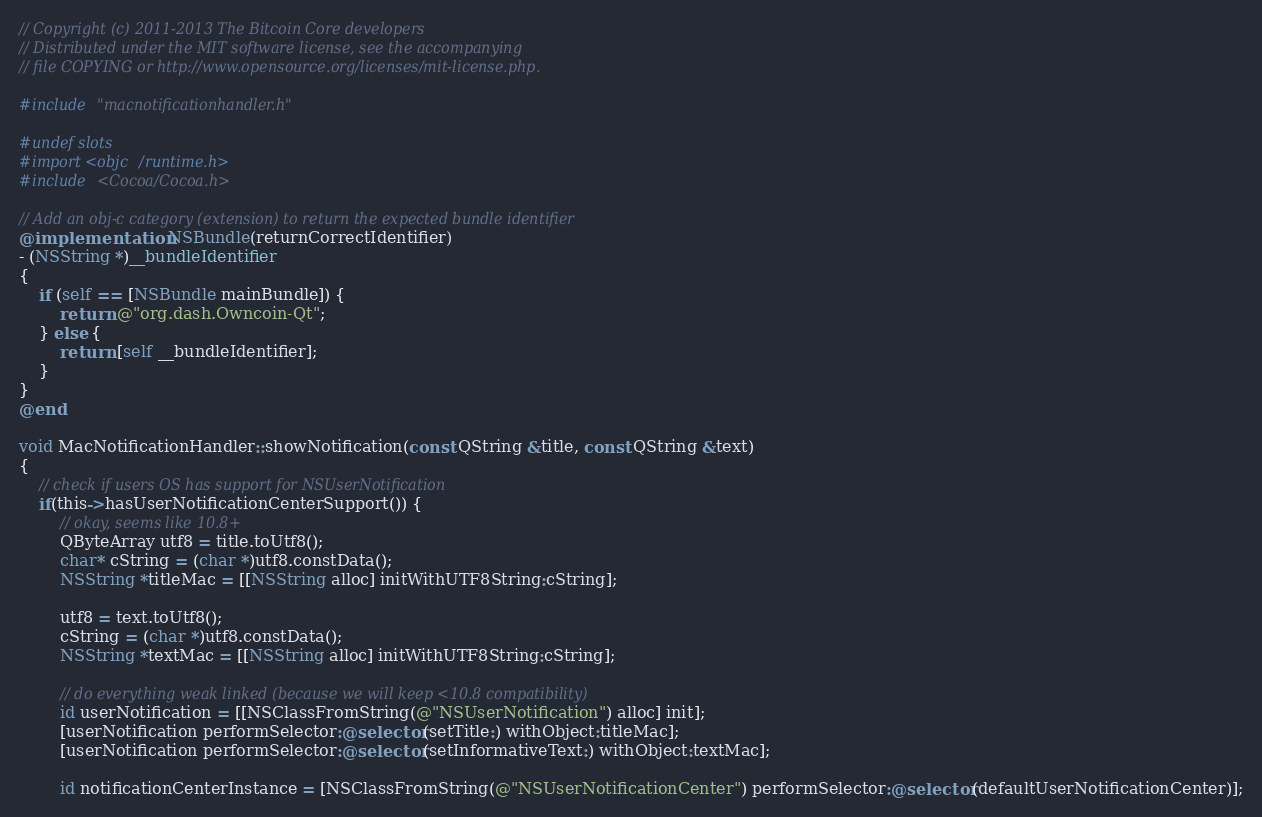<code> <loc_0><loc_0><loc_500><loc_500><_ObjectiveC_>// Copyright (c) 2011-2013 The Bitcoin Core developers
// Distributed under the MIT software license, see the accompanying
// file COPYING or http://www.opensource.org/licenses/mit-license.php.

#include "macnotificationhandler.h"

#undef slots
#import <objc/runtime.h>
#include <Cocoa/Cocoa.h>

// Add an obj-c category (extension) to return the expected bundle identifier
@implementation NSBundle(returnCorrectIdentifier)
- (NSString *)__bundleIdentifier
{
    if (self == [NSBundle mainBundle]) {
        return @"org.dash.Owncoin-Qt";
    } else {
        return [self __bundleIdentifier];
    }
}
@end

void MacNotificationHandler::showNotification(const QString &title, const QString &text)
{
    // check if users OS has support for NSUserNotification
    if(this->hasUserNotificationCenterSupport()) {
        // okay, seems like 10.8+
        QByteArray utf8 = title.toUtf8();
        char* cString = (char *)utf8.constData();
        NSString *titleMac = [[NSString alloc] initWithUTF8String:cString];

        utf8 = text.toUtf8();
        cString = (char *)utf8.constData();
        NSString *textMac = [[NSString alloc] initWithUTF8String:cString];

        // do everything weak linked (because we will keep <10.8 compatibility)
        id userNotification = [[NSClassFromString(@"NSUserNotification") alloc] init];
        [userNotification performSelector:@selector(setTitle:) withObject:titleMac];
        [userNotification performSelector:@selector(setInformativeText:) withObject:textMac];

        id notificationCenterInstance = [NSClassFromString(@"NSUserNotificationCenter") performSelector:@selector(defaultUserNotificationCenter)];</code> 